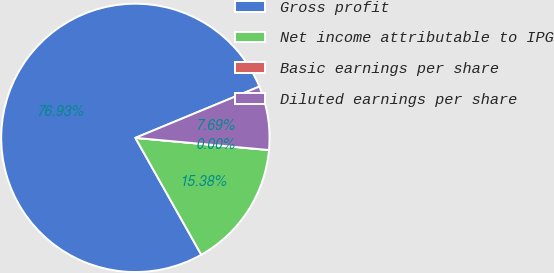Convert chart to OTSL. <chart><loc_0><loc_0><loc_500><loc_500><pie_chart><fcel>Gross profit<fcel>Net income attributable to IPG<fcel>Basic earnings per share<fcel>Diluted earnings per share<nl><fcel>76.92%<fcel>15.38%<fcel>0.0%<fcel>7.69%<nl></chart> 